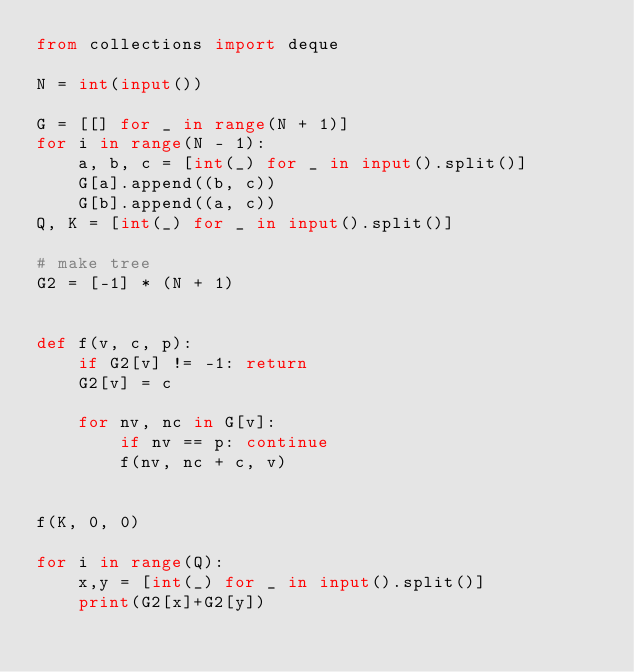Convert code to text. <code><loc_0><loc_0><loc_500><loc_500><_Python_>from collections import deque

N = int(input())

G = [[] for _ in range(N + 1)]
for i in range(N - 1):
    a, b, c = [int(_) for _ in input().split()]
    G[a].append((b, c))
    G[b].append((a, c))
Q, K = [int(_) for _ in input().split()]

# make tree
G2 = [-1] * (N + 1)


def f(v, c, p):
    if G2[v] != -1: return
    G2[v] = c

    for nv, nc in G[v]:
        if nv == p: continue
        f(nv, nc + c, v)


f(K, 0, 0)

for i in range(Q):
    x,y = [int(_) for _ in input().split()]
    print(G2[x]+G2[y])
</code> 